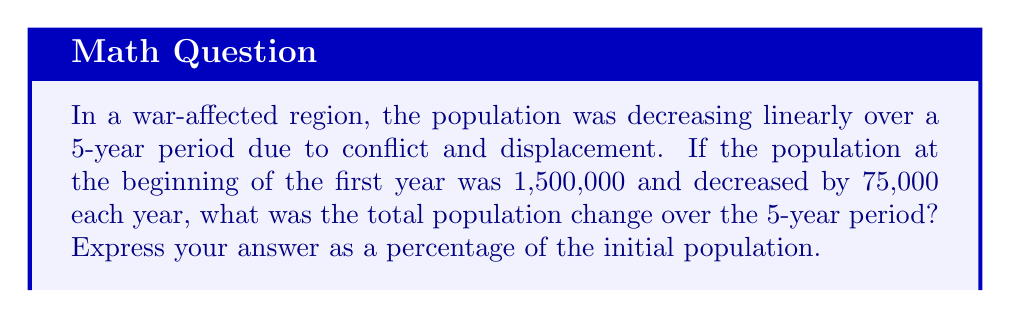What is the answer to this math problem? Let's approach this step-by-step using arithmetic progression:

1) The population forms an arithmetic sequence with:
   $a_1 = 1,500,000$ (first term)
   $d = -75,000$ (common difference)
   $n = 5$ (number of terms)

2) The population for each year can be represented as:
   Year 1: $a_1 = 1,500,000$
   Year 2: $a_2 = a_1 + d = 1,500,000 - 75,000 = 1,425,000$
   Year 3: $a_3 = a_2 + d = 1,425,000 - 75,000 = 1,350,000$
   Year 4: $a_4 = a_3 + d = 1,350,000 - 75,000 = 1,275,000$
   Year 5: $a_5 = a_4 + d = 1,275,000 - 75,000 = 1,200,000$

3) The total population change is the difference between the first and last term:
   $\text{Total change} = a_5 - a_1 = 1,200,000 - 1,500,000 = -300,000$

4) To express this as a percentage of the initial population:
   $$\text{Percentage change} = \frac{\text{Total change}}{\text{Initial population}} \times 100\%$$
   $$= \frac{-300,000}{1,500,000} \times 100\% = -20\%$$

Therefore, the total population change over the 5-year period was a decrease of 20% from the initial population.
Answer: -20% 